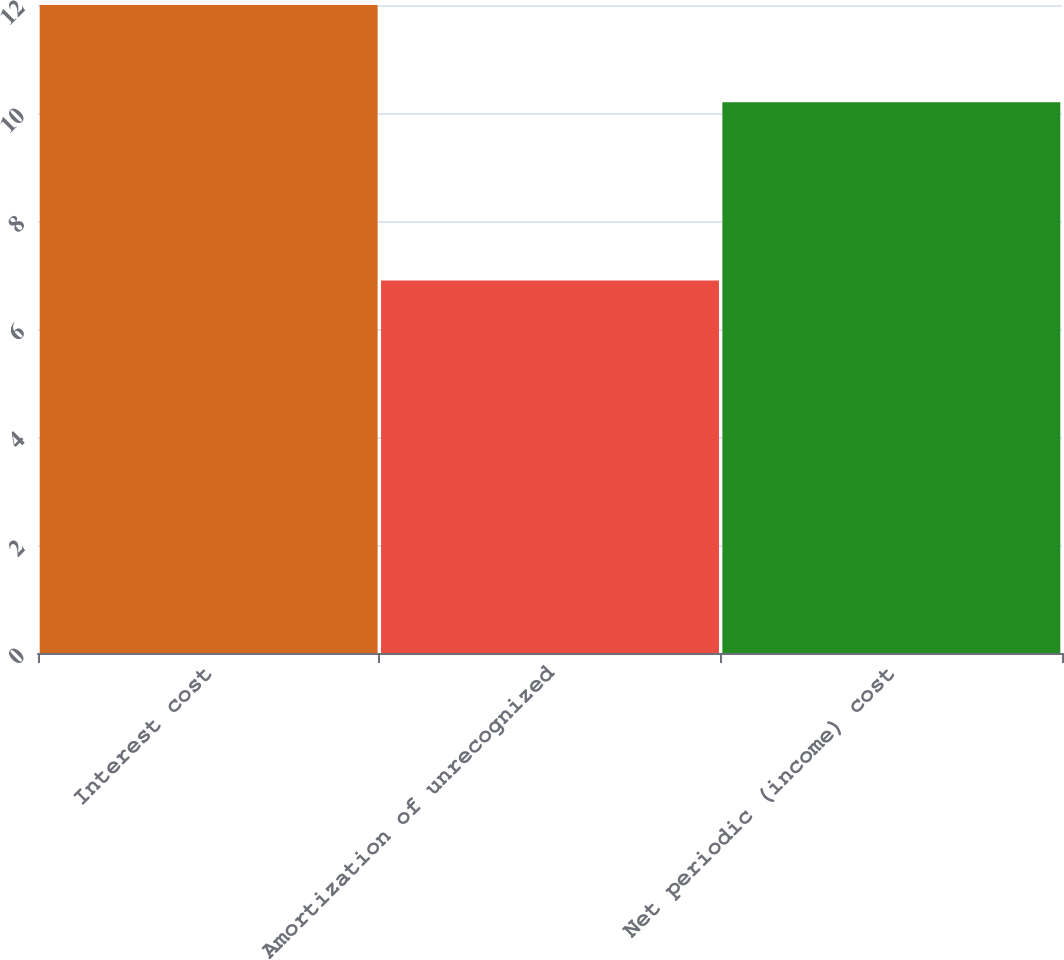<chart> <loc_0><loc_0><loc_500><loc_500><bar_chart><fcel>Interest cost<fcel>Amortization of unrecognized<fcel>Net periodic (income) cost<nl><fcel>12<fcel>6.9<fcel>10.2<nl></chart> 